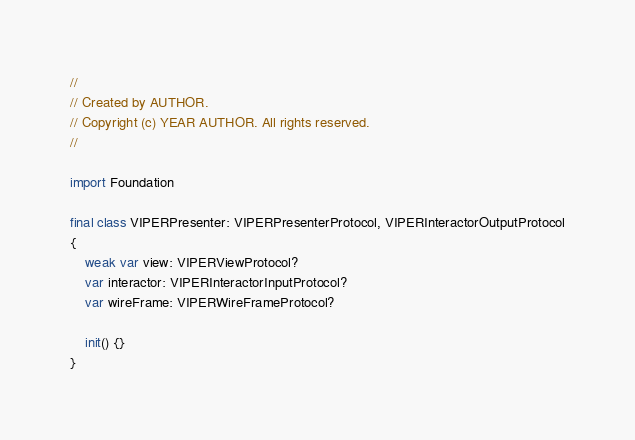<code> <loc_0><loc_0><loc_500><loc_500><_Swift_>//
// Created by AUTHOR.
// Copyright (c) YEAR AUTHOR. All rights reserved.
//

import Foundation

final class VIPERPresenter: VIPERPresenterProtocol, VIPERInteractorOutputProtocol
{
    weak var view: VIPERViewProtocol?
    var interactor: VIPERInteractorInputProtocol?
    var wireFrame: VIPERWireFrameProtocol?
    
    init() {}
}</code> 